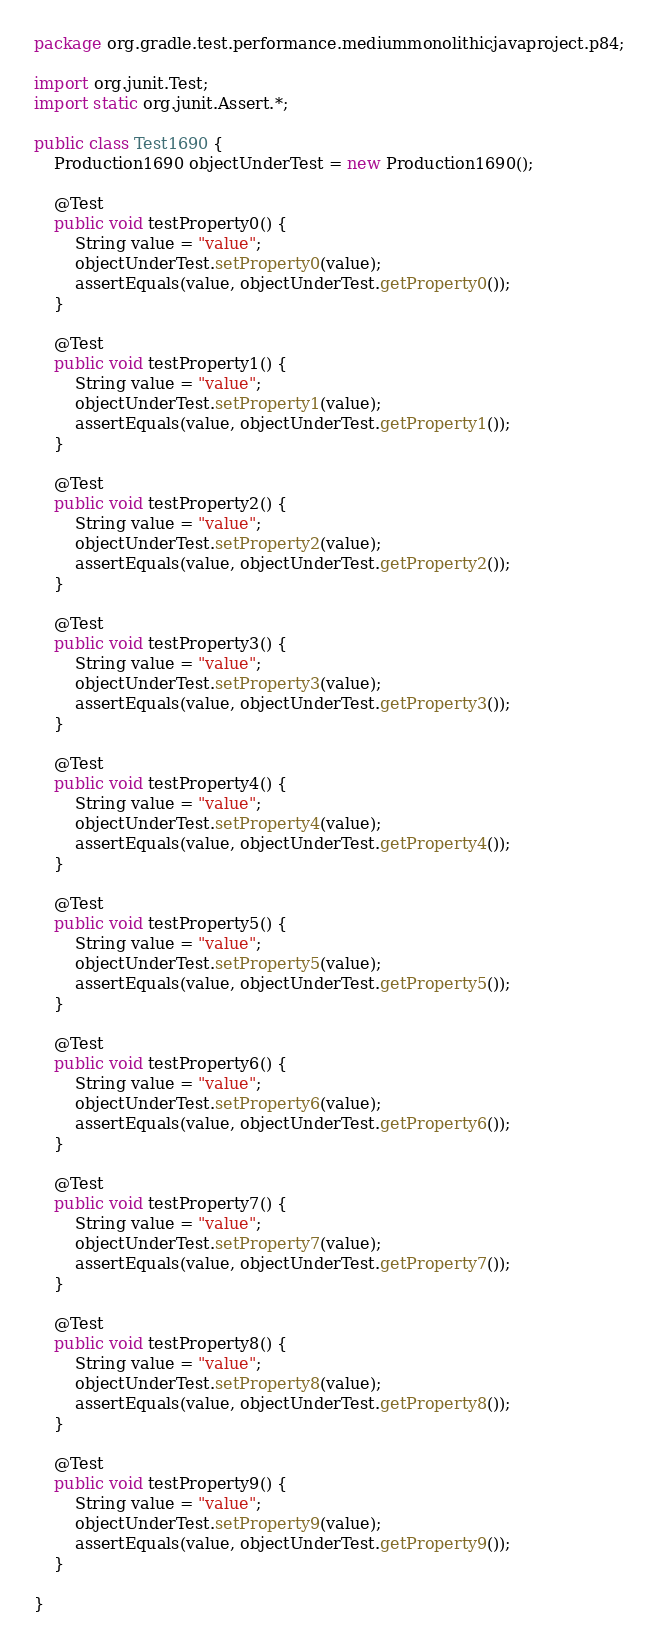<code> <loc_0><loc_0><loc_500><loc_500><_Java_>package org.gradle.test.performance.mediummonolithicjavaproject.p84;

import org.junit.Test;
import static org.junit.Assert.*;

public class Test1690 {  
    Production1690 objectUnderTest = new Production1690();     

    @Test
    public void testProperty0() {
        String value = "value";
        objectUnderTest.setProperty0(value);
        assertEquals(value, objectUnderTest.getProperty0());
    }

    @Test
    public void testProperty1() {
        String value = "value";
        objectUnderTest.setProperty1(value);
        assertEquals(value, objectUnderTest.getProperty1());
    }

    @Test
    public void testProperty2() {
        String value = "value";
        objectUnderTest.setProperty2(value);
        assertEquals(value, objectUnderTest.getProperty2());
    }

    @Test
    public void testProperty3() {
        String value = "value";
        objectUnderTest.setProperty3(value);
        assertEquals(value, objectUnderTest.getProperty3());
    }

    @Test
    public void testProperty4() {
        String value = "value";
        objectUnderTest.setProperty4(value);
        assertEquals(value, objectUnderTest.getProperty4());
    }

    @Test
    public void testProperty5() {
        String value = "value";
        objectUnderTest.setProperty5(value);
        assertEquals(value, objectUnderTest.getProperty5());
    }

    @Test
    public void testProperty6() {
        String value = "value";
        objectUnderTest.setProperty6(value);
        assertEquals(value, objectUnderTest.getProperty6());
    }

    @Test
    public void testProperty7() {
        String value = "value";
        objectUnderTest.setProperty7(value);
        assertEquals(value, objectUnderTest.getProperty7());
    }

    @Test
    public void testProperty8() {
        String value = "value";
        objectUnderTest.setProperty8(value);
        assertEquals(value, objectUnderTest.getProperty8());
    }

    @Test
    public void testProperty9() {
        String value = "value";
        objectUnderTest.setProperty9(value);
        assertEquals(value, objectUnderTest.getProperty9());
    }

}</code> 